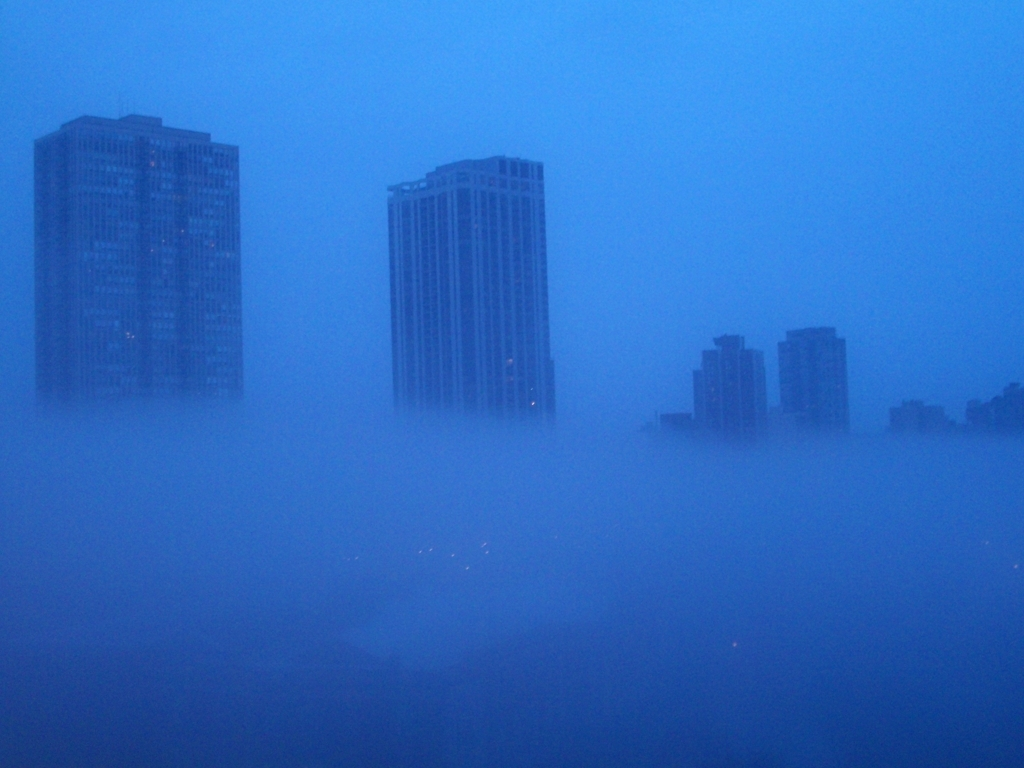What time of day do you think it is in this image, and why? It appears to be either early morning or late evening, as suggested by the presence of lights in the buildings. These are typically the times of day when artificial lighting is noticeable, and combined with the heavy fog, it hints at the transition periods between night and day where such atmospheric conditions are more common. 